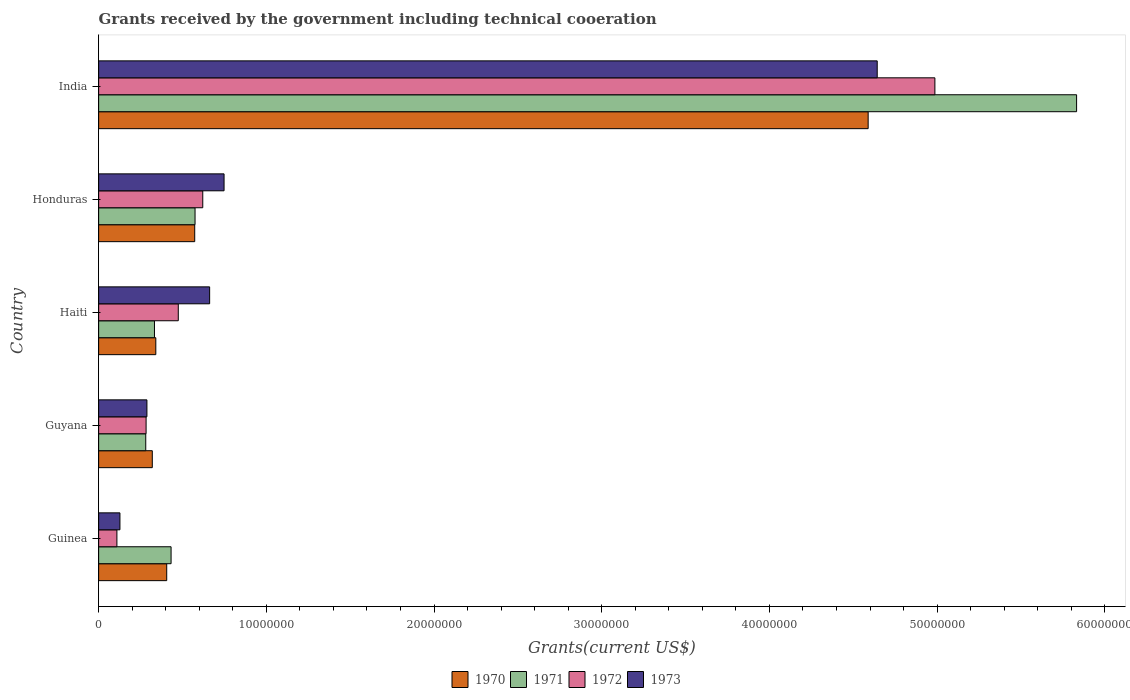How many different coloured bars are there?
Ensure brevity in your answer.  4. How many bars are there on the 4th tick from the top?
Your response must be concise. 4. How many bars are there on the 5th tick from the bottom?
Give a very brief answer. 4. What is the label of the 3rd group of bars from the top?
Provide a short and direct response. Haiti. In how many cases, is the number of bars for a given country not equal to the number of legend labels?
Keep it short and to the point. 0. What is the total grants received by the government in 1973 in Guinea?
Offer a very short reply. 1.27e+06. Across all countries, what is the maximum total grants received by the government in 1970?
Your response must be concise. 4.59e+07. Across all countries, what is the minimum total grants received by the government in 1971?
Your response must be concise. 2.81e+06. In which country was the total grants received by the government in 1970 minimum?
Your answer should be very brief. Guyana. What is the total total grants received by the government in 1972 in the graph?
Your answer should be compact. 6.48e+07. What is the difference between the total grants received by the government in 1972 in Haiti and that in Honduras?
Provide a succinct answer. -1.46e+06. What is the difference between the total grants received by the government in 1973 in India and the total grants received by the government in 1970 in Haiti?
Your answer should be very brief. 4.30e+07. What is the average total grants received by the government in 1971 per country?
Your answer should be very brief. 1.49e+07. What is the difference between the total grants received by the government in 1971 and total grants received by the government in 1972 in Haiti?
Give a very brief answer. -1.42e+06. In how many countries, is the total grants received by the government in 1970 greater than 58000000 US$?
Keep it short and to the point. 0. What is the ratio of the total grants received by the government in 1970 in Guyana to that in India?
Offer a very short reply. 0.07. Is the difference between the total grants received by the government in 1971 in Guinea and Guyana greater than the difference between the total grants received by the government in 1972 in Guinea and Guyana?
Make the answer very short. Yes. What is the difference between the highest and the second highest total grants received by the government in 1972?
Make the answer very short. 4.37e+07. What is the difference between the highest and the lowest total grants received by the government in 1971?
Your response must be concise. 5.55e+07. Is it the case that in every country, the sum of the total grants received by the government in 1972 and total grants received by the government in 1973 is greater than the sum of total grants received by the government in 1971 and total grants received by the government in 1970?
Provide a succinct answer. No. What does the 2nd bar from the bottom in Guyana represents?
Ensure brevity in your answer.  1971. How many bars are there?
Keep it short and to the point. 20. Are all the bars in the graph horizontal?
Keep it short and to the point. Yes. How many countries are there in the graph?
Provide a succinct answer. 5. Are the values on the major ticks of X-axis written in scientific E-notation?
Offer a very short reply. No. Does the graph contain any zero values?
Ensure brevity in your answer.  No. Does the graph contain grids?
Ensure brevity in your answer.  No. How many legend labels are there?
Your response must be concise. 4. What is the title of the graph?
Ensure brevity in your answer.  Grants received by the government including technical cooeration. What is the label or title of the X-axis?
Ensure brevity in your answer.  Grants(current US$). What is the Grants(current US$) of 1970 in Guinea?
Provide a succinct answer. 4.06e+06. What is the Grants(current US$) of 1971 in Guinea?
Your response must be concise. 4.32e+06. What is the Grants(current US$) of 1972 in Guinea?
Your answer should be very brief. 1.09e+06. What is the Grants(current US$) of 1973 in Guinea?
Make the answer very short. 1.27e+06. What is the Grants(current US$) in 1970 in Guyana?
Give a very brief answer. 3.20e+06. What is the Grants(current US$) of 1971 in Guyana?
Keep it short and to the point. 2.81e+06. What is the Grants(current US$) in 1972 in Guyana?
Your response must be concise. 2.83e+06. What is the Grants(current US$) of 1973 in Guyana?
Provide a short and direct response. 2.88e+06. What is the Grants(current US$) in 1970 in Haiti?
Your answer should be very brief. 3.41e+06. What is the Grants(current US$) in 1971 in Haiti?
Make the answer very short. 3.33e+06. What is the Grants(current US$) of 1972 in Haiti?
Ensure brevity in your answer.  4.75e+06. What is the Grants(current US$) of 1973 in Haiti?
Offer a terse response. 6.62e+06. What is the Grants(current US$) of 1970 in Honduras?
Ensure brevity in your answer.  5.73e+06. What is the Grants(current US$) in 1971 in Honduras?
Your answer should be very brief. 5.75e+06. What is the Grants(current US$) of 1972 in Honduras?
Ensure brevity in your answer.  6.21e+06. What is the Grants(current US$) of 1973 in Honduras?
Offer a very short reply. 7.48e+06. What is the Grants(current US$) in 1970 in India?
Offer a very short reply. 4.59e+07. What is the Grants(current US$) in 1971 in India?
Provide a short and direct response. 5.83e+07. What is the Grants(current US$) in 1972 in India?
Offer a very short reply. 4.99e+07. What is the Grants(current US$) in 1973 in India?
Your response must be concise. 4.64e+07. Across all countries, what is the maximum Grants(current US$) of 1970?
Provide a short and direct response. 4.59e+07. Across all countries, what is the maximum Grants(current US$) of 1971?
Keep it short and to the point. 5.83e+07. Across all countries, what is the maximum Grants(current US$) of 1972?
Ensure brevity in your answer.  4.99e+07. Across all countries, what is the maximum Grants(current US$) of 1973?
Your answer should be compact. 4.64e+07. Across all countries, what is the minimum Grants(current US$) of 1970?
Offer a terse response. 3.20e+06. Across all countries, what is the minimum Grants(current US$) in 1971?
Make the answer very short. 2.81e+06. Across all countries, what is the minimum Grants(current US$) in 1972?
Keep it short and to the point. 1.09e+06. Across all countries, what is the minimum Grants(current US$) of 1973?
Provide a succinct answer. 1.27e+06. What is the total Grants(current US$) of 1970 in the graph?
Your response must be concise. 6.23e+07. What is the total Grants(current US$) of 1971 in the graph?
Give a very brief answer. 7.45e+07. What is the total Grants(current US$) of 1972 in the graph?
Keep it short and to the point. 6.48e+07. What is the total Grants(current US$) in 1973 in the graph?
Provide a short and direct response. 6.47e+07. What is the difference between the Grants(current US$) of 1970 in Guinea and that in Guyana?
Offer a very short reply. 8.60e+05. What is the difference between the Grants(current US$) of 1971 in Guinea and that in Guyana?
Offer a terse response. 1.51e+06. What is the difference between the Grants(current US$) of 1972 in Guinea and that in Guyana?
Your answer should be compact. -1.74e+06. What is the difference between the Grants(current US$) in 1973 in Guinea and that in Guyana?
Your answer should be very brief. -1.61e+06. What is the difference between the Grants(current US$) of 1970 in Guinea and that in Haiti?
Your answer should be compact. 6.50e+05. What is the difference between the Grants(current US$) of 1971 in Guinea and that in Haiti?
Give a very brief answer. 9.90e+05. What is the difference between the Grants(current US$) of 1972 in Guinea and that in Haiti?
Give a very brief answer. -3.66e+06. What is the difference between the Grants(current US$) of 1973 in Guinea and that in Haiti?
Provide a succinct answer. -5.35e+06. What is the difference between the Grants(current US$) of 1970 in Guinea and that in Honduras?
Make the answer very short. -1.67e+06. What is the difference between the Grants(current US$) in 1971 in Guinea and that in Honduras?
Provide a succinct answer. -1.43e+06. What is the difference between the Grants(current US$) in 1972 in Guinea and that in Honduras?
Make the answer very short. -5.12e+06. What is the difference between the Grants(current US$) of 1973 in Guinea and that in Honduras?
Provide a succinct answer. -6.21e+06. What is the difference between the Grants(current US$) of 1970 in Guinea and that in India?
Provide a succinct answer. -4.18e+07. What is the difference between the Grants(current US$) of 1971 in Guinea and that in India?
Provide a succinct answer. -5.40e+07. What is the difference between the Grants(current US$) of 1972 in Guinea and that in India?
Your answer should be compact. -4.88e+07. What is the difference between the Grants(current US$) of 1973 in Guinea and that in India?
Your response must be concise. -4.52e+07. What is the difference between the Grants(current US$) in 1971 in Guyana and that in Haiti?
Give a very brief answer. -5.20e+05. What is the difference between the Grants(current US$) in 1972 in Guyana and that in Haiti?
Keep it short and to the point. -1.92e+06. What is the difference between the Grants(current US$) in 1973 in Guyana and that in Haiti?
Offer a very short reply. -3.74e+06. What is the difference between the Grants(current US$) in 1970 in Guyana and that in Honduras?
Your answer should be very brief. -2.53e+06. What is the difference between the Grants(current US$) of 1971 in Guyana and that in Honduras?
Ensure brevity in your answer.  -2.94e+06. What is the difference between the Grants(current US$) in 1972 in Guyana and that in Honduras?
Make the answer very short. -3.38e+06. What is the difference between the Grants(current US$) of 1973 in Guyana and that in Honduras?
Ensure brevity in your answer.  -4.60e+06. What is the difference between the Grants(current US$) in 1970 in Guyana and that in India?
Your answer should be compact. -4.27e+07. What is the difference between the Grants(current US$) in 1971 in Guyana and that in India?
Your answer should be very brief. -5.55e+07. What is the difference between the Grants(current US$) of 1972 in Guyana and that in India?
Provide a short and direct response. -4.70e+07. What is the difference between the Grants(current US$) of 1973 in Guyana and that in India?
Your response must be concise. -4.36e+07. What is the difference between the Grants(current US$) of 1970 in Haiti and that in Honduras?
Provide a succinct answer. -2.32e+06. What is the difference between the Grants(current US$) of 1971 in Haiti and that in Honduras?
Your response must be concise. -2.42e+06. What is the difference between the Grants(current US$) of 1972 in Haiti and that in Honduras?
Give a very brief answer. -1.46e+06. What is the difference between the Grants(current US$) in 1973 in Haiti and that in Honduras?
Offer a terse response. -8.60e+05. What is the difference between the Grants(current US$) of 1970 in Haiti and that in India?
Offer a terse response. -4.25e+07. What is the difference between the Grants(current US$) of 1971 in Haiti and that in India?
Your response must be concise. -5.50e+07. What is the difference between the Grants(current US$) in 1972 in Haiti and that in India?
Provide a succinct answer. -4.51e+07. What is the difference between the Grants(current US$) of 1973 in Haiti and that in India?
Ensure brevity in your answer.  -3.98e+07. What is the difference between the Grants(current US$) in 1970 in Honduras and that in India?
Offer a very short reply. -4.02e+07. What is the difference between the Grants(current US$) of 1971 in Honduras and that in India?
Provide a succinct answer. -5.26e+07. What is the difference between the Grants(current US$) in 1972 in Honduras and that in India?
Your answer should be compact. -4.37e+07. What is the difference between the Grants(current US$) of 1973 in Honduras and that in India?
Keep it short and to the point. -3.90e+07. What is the difference between the Grants(current US$) in 1970 in Guinea and the Grants(current US$) in 1971 in Guyana?
Offer a terse response. 1.25e+06. What is the difference between the Grants(current US$) in 1970 in Guinea and the Grants(current US$) in 1972 in Guyana?
Provide a short and direct response. 1.23e+06. What is the difference between the Grants(current US$) in 1970 in Guinea and the Grants(current US$) in 1973 in Guyana?
Your answer should be compact. 1.18e+06. What is the difference between the Grants(current US$) in 1971 in Guinea and the Grants(current US$) in 1972 in Guyana?
Ensure brevity in your answer.  1.49e+06. What is the difference between the Grants(current US$) in 1971 in Guinea and the Grants(current US$) in 1973 in Guyana?
Your answer should be compact. 1.44e+06. What is the difference between the Grants(current US$) of 1972 in Guinea and the Grants(current US$) of 1973 in Guyana?
Keep it short and to the point. -1.79e+06. What is the difference between the Grants(current US$) in 1970 in Guinea and the Grants(current US$) in 1971 in Haiti?
Provide a short and direct response. 7.30e+05. What is the difference between the Grants(current US$) of 1970 in Guinea and the Grants(current US$) of 1972 in Haiti?
Make the answer very short. -6.90e+05. What is the difference between the Grants(current US$) of 1970 in Guinea and the Grants(current US$) of 1973 in Haiti?
Provide a succinct answer. -2.56e+06. What is the difference between the Grants(current US$) of 1971 in Guinea and the Grants(current US$) of 1972 in Haiti?
Make the answer very short. -4.30e+05. What is the difference between the Grants(current US$) of 1971 in Guinea and the Grants(current US$) of 1973 in Haiti?
Offer a terse response. -2.30e+06. What is the difference between the Grants(current US$) of 1972 in Guinea and the Grants(current US$) of 1973 in Haiti?
Give a very brief answer. -5.53e+06. What is the difference between the Grants(current US$) of 1970 in Guinea and the Grants(current US$) of 1971 in Honduras?
Your answer should be very brief. -1.69e+06. What is the difference between the Grants(current US$) in 1970 in Guinea and the Grants(current US$) in 1972 in Honduras?
Your response must be concise. -2.15e+06. What is the difference between the Grants(current US$) in 1970 in Guinea and the Grants(current US$) in 1973 in Honduras?
Ensure brevity in your answer.  -3.42e+06. What is the difference between the Grants(current US$) of 1971 in Guinea and the Grants(current US$) of 1972 in Honduras?
Your response must be concise. -1.89e+06. What is the difference between the Grants(current US$) of 1971 in Guinea and the Grants(current US$) of 1973 in Honduras?
Ensure brevity in your answer.  -3.16e+06. What is the difference between the Grants(current US$) in 1972 in Guinea and the Grants(current US$) in 1973 in Honduras?
Make the answer very short. -6.39e+06. What is the difference between the Grants(current US$) of 1970 in Guinea and the Grants(current US$) of 1971 in India?
Your answer should be very brief. -5.43e+07. What is the difference between the Grants(current US$) in 1970 in Guinea and the Grants(current US$) in 1972 in India?
Your answer should be very brief. -4.58e+07. What is the difference between the Grants(current US$) of 1970 in Guinea and the Grants(current US$) of 1973 in India?
Ensure brevity in your answer.  -4.24e+07. What is the difference between the Grants(current US$) in 1971 in Guinea and the Grants(current US$) in 1972 in India?
Keep it short and to the point. -4.56e+07. What is the difference between the Grants(current US$) of 1971 in Guinea and the Grants(current US$) of 1973 in India?
Provide a short and direct response. -4.21e+07. What is the difference between the Grants(current US$) of 1972 in Guinea and the Grants(current US$) of 1973 in India?
Offer a very short reply. -4.53e+07. What is the difference between the Grants(current US$) in 1970 in Guyana and the Grants(current US$) in 1971 in Haiti?
Give a very brief answer. -1.30e+05. What is the difference between the Grants(current US$) of 1970 in Guyana and the Grants(current US$) of 1972 in Haiti?
Your answer should be very brief. -1.55e+06. What is the difference between the Grants(current US$) in 1970 in Guyana and the Grants(current US$) in 1973 in Haiti?
Give a very brief answer. -3.42e+06. What is the difference between the Grants(current US$) of 1971 in Guyana and the Grants(current US$) of 1972 in Haiti?
Provide a succinct answer. -1.94e+06. What is the difference between the Grants(current US$) of 1971 in Guyana and the Grants(current US$) of 1973 in Haiti?
Offer a terse response. -3.81e+06. What is the difference between the Grants(current US$) in 1972 in Guyana and the Grants(current US$) in 1973 in Haiti?
Keep it short and to the point. -3.79e+06. What is the difference between the Grants(current US$) in 1970 in Guyana and the Grants(current US$) in 1971 in Honduras?
Offer a terse response. -2.55e+06. What is the difference between the Grants(current US$) of 1970 in Guyana and the Grants(current US$) of 1972 in Honduras?
Provide a short and direct response. -3.01e+06. What is the difference between the Grants(current US$) in 1970 in Guyana and the Grants(current US$) in 1973 in Honduras?
Offer a terse response. -4.28e+06. What is the difference between the Grants(current US$) in 1971 in Guyana and the Grants(current US$) in 1972 in Honduras?
Your answer should be very brief. -3.40e+06. What is the difference between the Grants(current US$) of 1971 in Guyana and the Grants(current US$) of 1973 in Honduras?
Provide a succinct answer. -4.67e+06. What is the difference between the Grants(current US$) in 1972 in Guyana and the Grants(current US$) in 1973 in Honduras?
Your response must be concise. -4.65e+06. What is the difference between the Grants(current US$) of 1970 in Guyana and the Grants(current US$) of 1971 in India?
Ensure brevity in your answer.  -5.51e+07. What is the difference between the Grants(current US$) in 1970 in Guyana and the Grants(current US$) in 1972 in India?
Your answer should be compact. -4.67e+07. What is the difference between the Grants(current US$) of 1970 in Guyana and the Grants(current US$) of 1973 in India?
Ensure brevity in your answer.  -4.32e+07. What is the difference between the Grants(current US$) of 1971 in Guyana and the Grants(current US$) of 1972 in India?
Your answer should be very brief. -4.71e+07. What is the difference between the Grants(current US$) in 1971 in Guyana and the Grants(current US$) in 1973 in India?
Your answer should be compact. -4.36e+07. What is the difference between the Grants(current US$) in 1972 in Guyana and the Grants(current US$) in 1973 in India?
Provide a succinct answer. -4.36e+07. What is the difference between the Grants(current US$) of 1970 in Haiti and the Grants(current US$) of 1971 in Honduras?
Offer a very short reply. -2.34e+06. What is the difference between the Grants(current US$) in 1970 in Haiti and the Grants(current US$) in 1972 in Honduras?
Ensure brevity in your answer.  -2.80e+06. What is the difference between the Grants(current US$) in 1970 in Haiti and the Grants(current US$) in 1973 in Honduras?
Provide a succinct answer. -4.07e+06. What is the difference between the Grants(current US$) of 1971 in Haiti and the Grants(current US$) of 1972 in Honduras?
Ensure brevity in your answer.  -2.88e+06. What is the difference between the Grants(current US$) in 1971 in Haiti and the Grants(current US$) in 1973 in Honduras?
Keep it short and to the point. -4.15e+06. What is the difference between the Grants(current US$) of 1972 in Haiti and the Grants(current US$) of 1973 in Honduras?
Your response must be concise. -2.73e+06. What is the difference between the Grants(current US$) in 1970 in Haiti and the Grants(current US$) in 1971 in India?
Offer a very short reply. -5.49e+07. What is the difference between the Grants(current US$) of 1970 in Haiti and the Grants(current US$) of 1972 in India?
Offer a very short reply. -4.65e+07. What is the difference between the Grants(current US$) in 1970 in Haiti and the Grants(current US$) in 1973 in India?
Offer a terse response. -4.30e+07. What is the difference between the Grants(current US$) of 1971 in Haiti and the Grants(current US$) of 1972 in India?
Keep it short and to the point. -4.65e+07. What is the difference between the Grants(current US$) of 1971 in Haiti and the Grants(current US$) of 1973 in India?
Your answer should be very brief. -4.31e+07. What is the difference between the Grants(current US$) in 1972 in Haiti and the Grants(current US$) in 1973 in India?
Offer a terse response. -4.17e+07. What is the difference between the Grants(current US$) of 1970 in Honduras and the Grants(current US$) of 1971 in India?
Ensure brevity in your answer.  -5.26e+07. What is the difference between the Grants(current US$) of 1970 in Honduras and the Grants(current US$) of 1972 in India?
Your response must be concise. -4.41e+07. What is the difference between the Grants(current US$) in 1970 in Honduras and the Grants(current US$) in 1973 in India?
Make the answer very short. -4.07e+07. What is the difference between the Grants(current US$) in 1971 in Honduras and the Grants(current US$) in 1972 in India?
Ensure brevity in your answer.  -4.41e+07. What is the difference between the Grants(current US$) of 1971 in Honduras and the Grants(current US$) of 1973 in India?
Your answer should be compact. -4.07e+07. What is the difference between the Grants(current US$) of 1972 in Honduras and the Grants(current US$) of 1973 in India?
Ensure brevity in your answer.  -4.02e+07. What is the average Grants(current US$) of 1970 per country?
Make the answer very short. 1.25e+07. What is the average Grants(current US$) of 1971 per country?
Offer a very short reply. 1.49e+07. What is the average Grants(current US$) of 1972 per country?
Provide a succinct answer. 1.30e+07. What is the average Grants(current US$) of 1973 per country?
Your answer should be compact. 1.29e+07. What is the difference between the Grants(current US$) of 1970 and Grants(current US$) of 1971 in Guinea?
Your answer should be very brief. -2.60e+05. What is the difference between the Grants(current US$) of 1970 and Grants(current US$) of 1972 in Guinea?
Provide a succinct answer. 2.97e+06. What is the difference between the Grants(current US$) of 1970 and Grants(current US$) of 1973 in Guinea?
Keep it short and to the point. 2.79e+06. What is the difference between the Grants(current US$) in 1971 and Grants(current US$) in 1972 in Guinea?
Your response must be concise. 3.23e+06. What is the difference between the Grants(current US$) of 1971 and Grants(current US$) of 1973 in Guinea?
Provide a succinct answer. 3.05e+06. What is the difference between the Grants(current US$) in 1970 and Grants(current US$) in 1972 in Guyana?
Your answer should be very brief. 3.70e+05. What is the difference between the Grants(current US$) in 1971 and Grants(current US$) in 1972 in Guyana?
Give a very brief answer. -2.00e+04. What is the difference between the Grants(current US$) in 1972 and Grants(current US$) in 1973 in Guyana?
Provide a succinct answer. -5.00e+04. What is the difference between the Grants(current US$) in 1970 and Grants(current US$) in 1972 in Haiti?
Provide a succinct answer. -1.34e+06. What is the difference between the Grants(current US$) of 1970 and Grants(current US$) of 1973 in Haiti?
Ensure brevity in your answer.  -3.21e+06. What is the difference between the Grants(current US$) of 1971 and Grants(current US$) of 1972 in Haiti?
Offer a very short reply. -1.42e+06. What is the difference between the Grants(current US$) of 1971 and Grants(current US$) of 1973 in Haiti?
Your response must be concise. -3.29e+06. What is the difference between the Grants(current US$) of 1972 and Grants(current US$) of 1973 in Haiti?
Give a very brief answer. -1.87e+06. What is the difference between the Grants(current US$) of 1970 and Grants(current US$) of 1971 in Honduras?
Make the answer very short. -2.00e+04. What is the difference between the Grants(current US$) of 1970 and Grants(current US$) of 1972 in Honduras?
Offer a very short reply. -4.80e+05. What is the difference between the Grants(current US$) of 1970 and Grants(current US$) of 1973 in Honduras?
Your answer should be very brief. -1.75e+06. What is the difference between the Grants(current US$) in 1971 and Grants(current US$) in 1972 in Honduras?
Provide a succinct answer. -4.60e+05. What is the difference between the Grants(current US$) of 1971 and Grants(current US$) of 1973 in Honduras?
Your answer should be compact. -1.73e+06. What is the difference between the Grants(current US$) in 1972 and Grants(current US$) in 1973 in Honduras?
Your answer should be very brief. -1.27e+06. What is the difference between the Grants(current US$) of 1970 and Grants(current US$) of 1971 in India?
Provide a short and direct response. -1.24e+07. What is the difference between the Grants(current US$) in 1970 and Grants(current US$) in 1972 in India?
Your answer should be compact. -3.98e+06. What is the difference between the Grants(current US$) in 1970 and Grants(current US$) in 1973 in India?
Provide a succinct answer. -5.40e+05. What is the difference between the Grants(current US$) of 1971 and Grants(current US$) of 1972 in India?
Your response must be concise. 8.45e+06. What is the difference between the Grants(current US$) of 1971 and Grants(current US$) of 1973 in India?
Offer a terse response. 1.19e+07. What is the difference between the Grants(current US$) in 1972 and Grants(current US$) in 1973 in India?
Provide a short and direct response. 3.44e+06. What is the ratio of the Grants(current US$) of 1970 in Guinea to that in Guyana?
Keep it short and to the point. 1.27. What is the ratio of the Grants(current US$) of 1971 in Guinea to that in Guyana?
Provide a short and direct response. 1.54. What is the ratio of the Grants(current US$) in 1972 in Guinea to that in Guyana?
Make the answer very short. 0.39. What is the ratio of the Grants(current US$) of 1973 in Guinea to that in Guyana?
Give a very brief answer. 0.44. What is the ratio of the Grants(current US$) of 1970 in Guinea to that in Haiti?
Your response must be concise. 1.19. What is the ratio of the Grants(current US$) in 1971 in Guinea to that in Haiti?
Offer a terse response. 1.3. What is the ratio of the Grants(current US$) in 1972 in Guinea to that in Haiti?
Provide a short and direct response. 0.23. What is the ratio of the Grants(current US$) of 1973 in Guinea to that in Haiti?
Your response must be concise. 0.19. What is the ratio of the Grants(current US$) in 1970 in Guinea to that in Honduras?
Your answer should be compact. 0.71. What is the ratio of the Grants(current US$) in 1971 in Guinea to that in Honduras?
Give a very brief answer. 0.75. What is the ratio of the Grants(current US$) in 1972 in Guinea to that in Honduras?
Provide a short and direct response. 0.18. What is the ratio of the Grants(current US$) of 1973 in Guinea to that in Honduras?
Offer a terse response. 0.17. What is the ratio of the Grants(current US$) in 1970 in Guinea to that in India?
Your answer should be very brief. 0.09. What is the ratio of the Grants(current US$) of 1971 in Guinea to that in India?
Give a very brief answer. 0.07. What is the ratio of the Grants(current US$) in 1972 in Guinea to that in India?
Your answer should be compact. 0.02. What is the ratio of the Grants(current US$) of 1973 in Guinea to that in India?
Provide a succinct answer. 0.03. What is the ratio of the Grants(current US$) in 1970 in Guyana to that in Haiti?
Give a very brief answer. 0.94. What is the ratio of the Grants(current US$) of 1971 in Guyana to that in Haiti?
Provide a short and direct response. 0.84. What is the ratio of the Grants(current US$) of 1972 in Guyana to that in Haiti?
Offer a terse response. 0.6. What is the ratio of the Grants(current US$) in 1973 in Guyana to that in Haiti?
Offer a terse response. 0.43. What is the ratio of the Grants(current US$) in 1970 in Guyana to that in Honduras?
Ensure brevity in your answer.  0.56. What is the ratio of the Grants(current US$) of 1971 in Guyana to that in Honduras?
Offer a very short reply. 0.49. What is the ratio of the Grants(current US$) of 1972 in Guyana to that in Honduras?
Make the answer very short. 0.46. What is the ratio of the Grants(current US$) in 1973 in Guyana to that in Honduras?
Your answer should be very brief. 0.39. What is the ratio of the Grants(current US$) of 1970 in Guyana to that in India?
Your answer should be very brief. 0.07. What is the ratio of the Grants(current US$) in 1971 in Guyana to that in India?
Offer a terse response. 0.05. What is the ratio of the Grants(current US$) of 1972 in Guyana to that in India?
Make the answer very short. 0.06. What is the ratio of the Grants(current US$) of 1973 in Guyana to that in India?
Offer a very short reply. 0.06. What is the ratio of the Grants(current US$) in 1970 in Haiti to that in Honduras?
Ensure brevity in your answer.  0.6. What is the ratio of the Grants(current US$) in 1971 in Haiti to that in Honduras?
Offer a terse response. 0.58. What is the ratio of the Grants(current US$) of 1972 in Haiti to that in Honduras?
Make the answer very short. 0.76. What is the ratio of the Grants(current US$) in 1973 in Haiti to that in Honduras?
Your answer should be compact. 0.89. What is the ratio of the Grants(current US$) of 1970 in Haiti to that in India?
Offer a very short reply. 0.07. What is the ratio of the Grants(current US$) of 1971 in Haiti to that in India?
Keep it short and to the point. 0.06. What is the ratio of the Grants(current US$) of 1972 in Haiti to that in India?
Your answer should be very brief. 0.1. What is the ratio of the Grants(current US$) of 1973 in Haiti to that in India?
Provide a short and direct response. 0.14. What is the ratio of the Grants(current US$) in 1970 in Honduras to that in India?
Your answer should be very brief. 0.12. What is the ratio of the Grants(current US$) of 1971 in Honduras to that in India?
Offer a terse response. 0.1. What is the ratio of the Grants(current US$) of 1972 in Honduras to that in India?
Keep it short and to the point. 0.12. What is the ratio of the Grants(current US$) in 1973 in Honduras to that in India?
Your response must be concise. 0.16. What is the difference between the highest and the second highest Grants(current US$) in 1970?
Provide a short and direct response. 4.02e+07. What is the difference between the highest and the second highest Grants(current US$) of 1971?
Keep it short and to the point. 5.26e+07. What is the difference between the highest and the second highest Grants(current US$) of 1972?
Provide a short and direct response. 4.37e+07. What is the difference between the highest and the second highest Grants(current US$) of 1973?
Your answer should be compact. 3.90e+07. What is the difference between the highest and the lowest Grants(current US$) of 1970?
Make the answer very short. 4.27e+07. What is the difference between the highest and the lowest Grants(current US$) of 1971?
Offer a very short reply. 5.55e+07. What is the difference between the highest and the lowest Grants(current US$) in 1972?
Provide a short and direct response. 4.88e+07. What is the difference between the highest and the lowest Grants(current US$) of 1973?
Offer a terse response. 4.52e+07. 